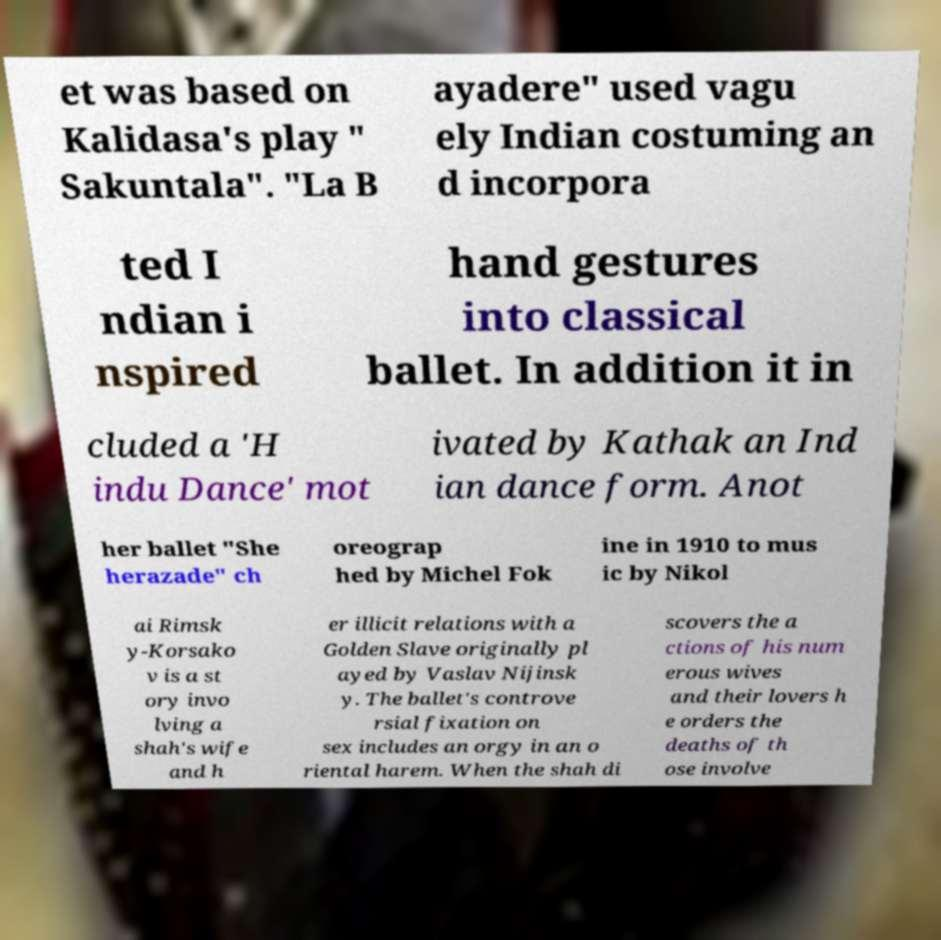Could you extract and type out the text from this image? et was based on Kalidasa's play " Sakuntala". "La B ayadere" used vagu ely Indian costuming an d incorpora ted I ndian i nspired hand gestures into classical ballet. In addition it in cluded a 'H indu Dance' mot ivated by Kathak an Ind ian dance form. Anot her ballet "She herazade" ch oreograp hed by Michel Fok ine in 1910 to mus ic by Nikol ai Rimsk y-Korsako v is a st ory invo lving a shah's wife and h er illicit relations with a Golden Slave originally pl ayed by Vaslav Nijinsk y. The ballet's controve rsial fixation on sex includes an orgy in an o riental harem. When the shah di scovers the a ctions of his num erous wives and their lovers h e orders the deaths of th ose involve 